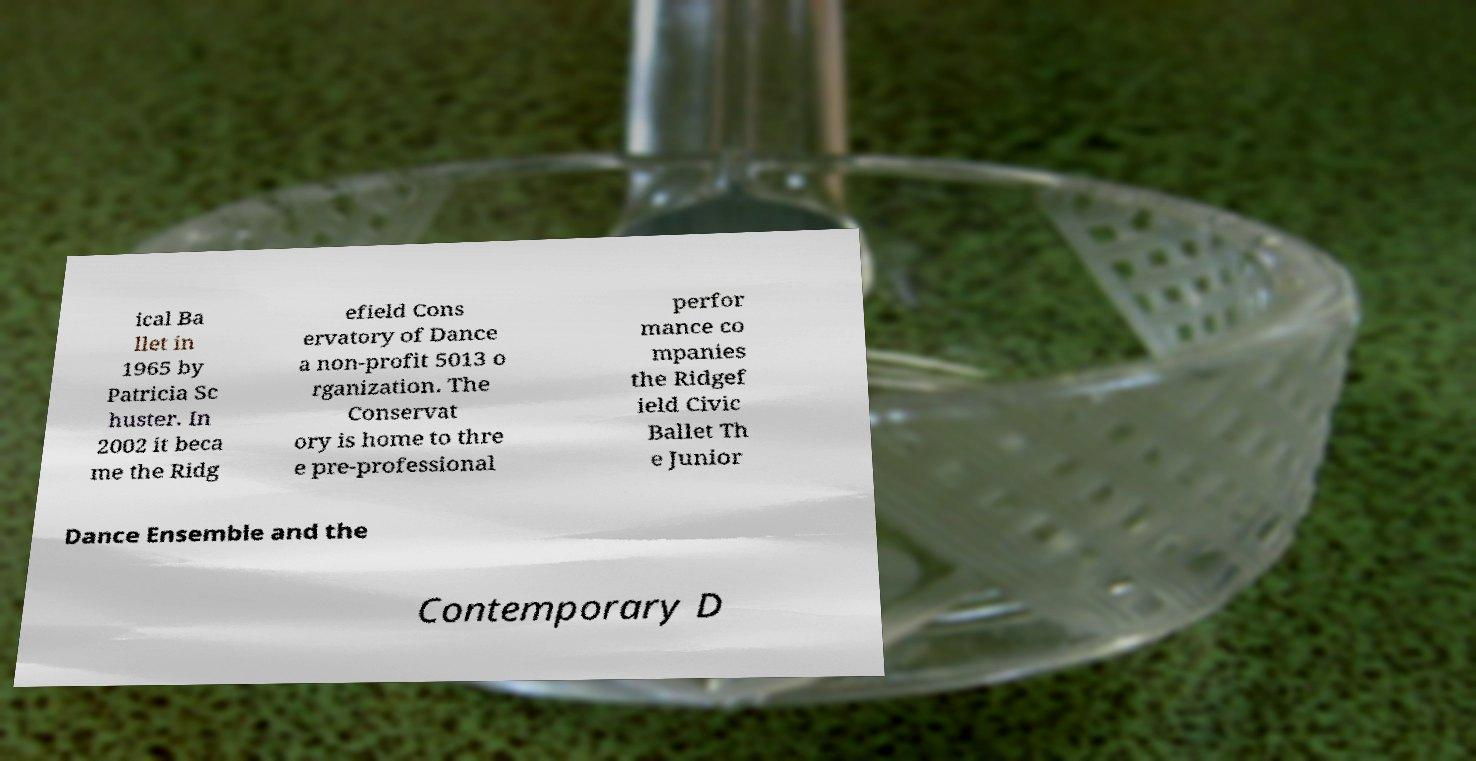Can you read and provide the text displayed in the image?This photo seems to have some interesting text. Can you extract and type it out for me? ical Ba llet in 1965 by Patricia Sc huster. In 2002 it beca me the Ridg efield Cons ervatory of Dance a non-profit 5013 o rganization. The Conservat ory is home to thre e pre-professional perfor mance co mpanies the Ridgef ield Civic Ballet Th e Junior Dance Ensemble and the Contemporary D 